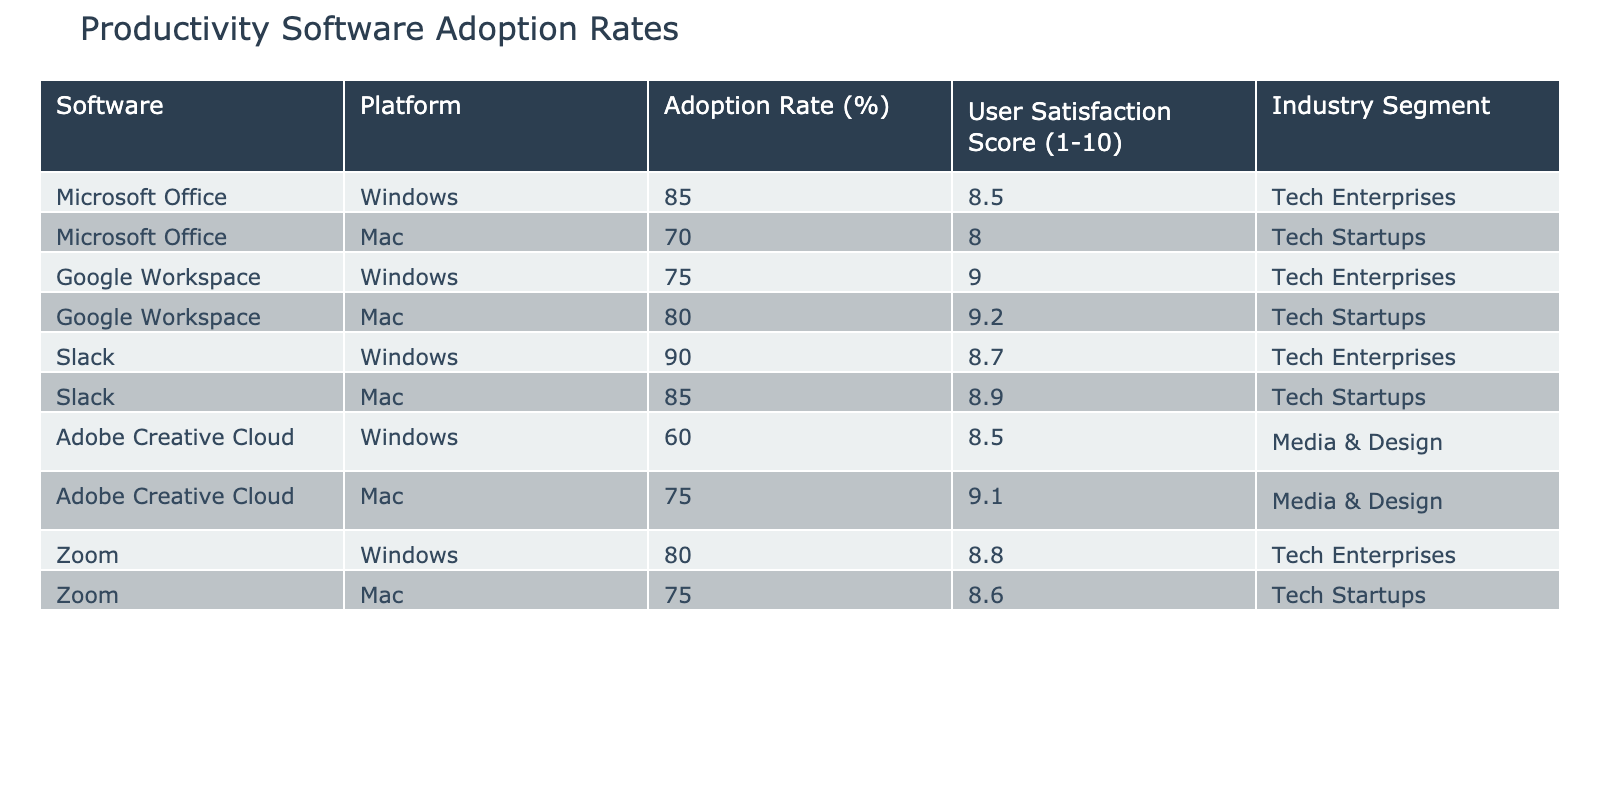What is the adoption rate of Microsoft Office on Mac? The table shows that the adoption rate of Microsoft Office on Mac systems is 70%.
Answer: 70% Which software has the highest user satisfaction score on Mac? By examining the user satisfaction scores in the table, Adobe Creative Cloud has the highest score of 9.1 on Mac systems.
Answer: Adobe Creative Cloud What is the difference in adoption rates between Google Workspace on Mac and Windows? The adoption rate for Google Workspace on Mac is 80%, and on Windows, it is 75%. The difference is calculated as 80% - 75% = 5%.
Answer: 5% Is the adoption rate of Slack higher on Windows than on Mac? The adoption rate of Slack on Windows is 90%, while on Mac, it is 85%. Since 90% is greater than 85%, the statement is true.
Answer: Yes What is the average user satisfaction score for all products on Mac? The user satisfaction scores for Mac are: 8.0 (Microsoft Office), 9.2 (Google Workspace), 8.9 (Slack), 9.1 (Adobe Creative Cloud), and 8.6 (Zoom). The average score is (8.0 + 9.2 + 8.9 + 9.1 + 8.6) / 5 = 8.76.
Answer: 8.76 What is the total adoption rate of media and design software on Mac? The adoption rates for media and design software on Mac are 75% (Adobe Creative Cloud). Since it is the only software in that category, the total adoption rate is 75%.
Answer: 75% Does Google Workspace have a higher adoption rate than Microsoft Office on Windows? The adoption rate for Google Workspace on Windows is 75%, while for Microsoft Office it is 85%. 85% is greater than 75%, making this statement false.
Answer: No Which platform has a higher user satisfaction score for Slack? On Mac, Slack has a user satisfaction score of 8.9, while on Windows, it is 8.7. Since 8.9 is greater than 8.7, Mac has a higher score.
Answer: Mac 